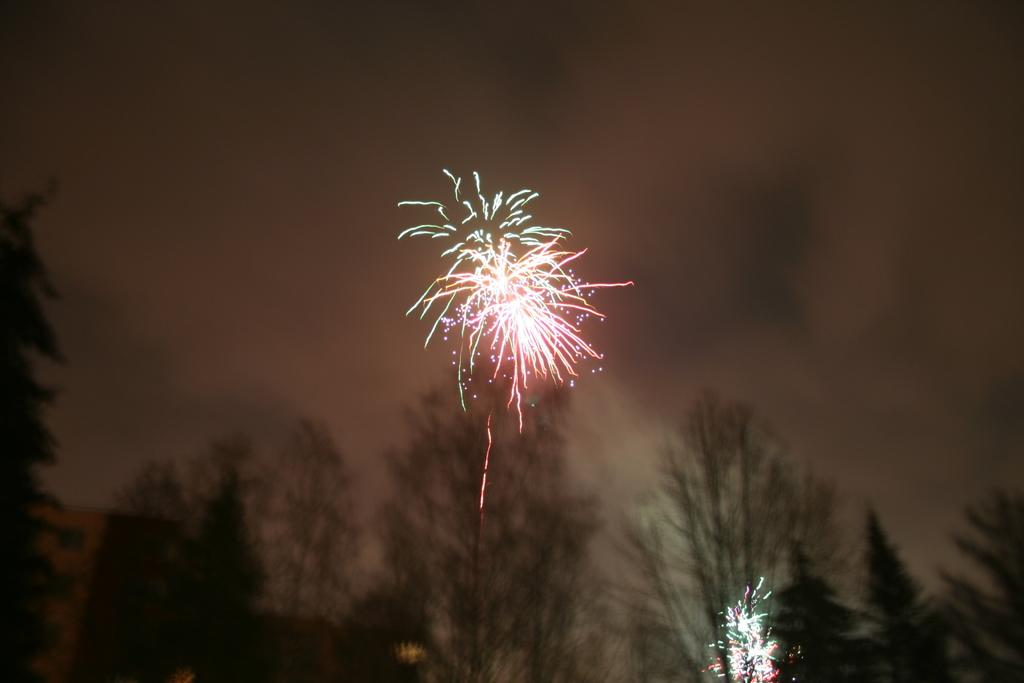What type of vegetation is present on the ground in the image? There are trees on the ground in the image. What can be seen in the background of the image? In the background, there are fireworks and clouds in the sky. What type of tin can be seen on the ship in the image? There is no ship or tin present in the image. What is the arm doing in the image? There is no arm present in the image. 